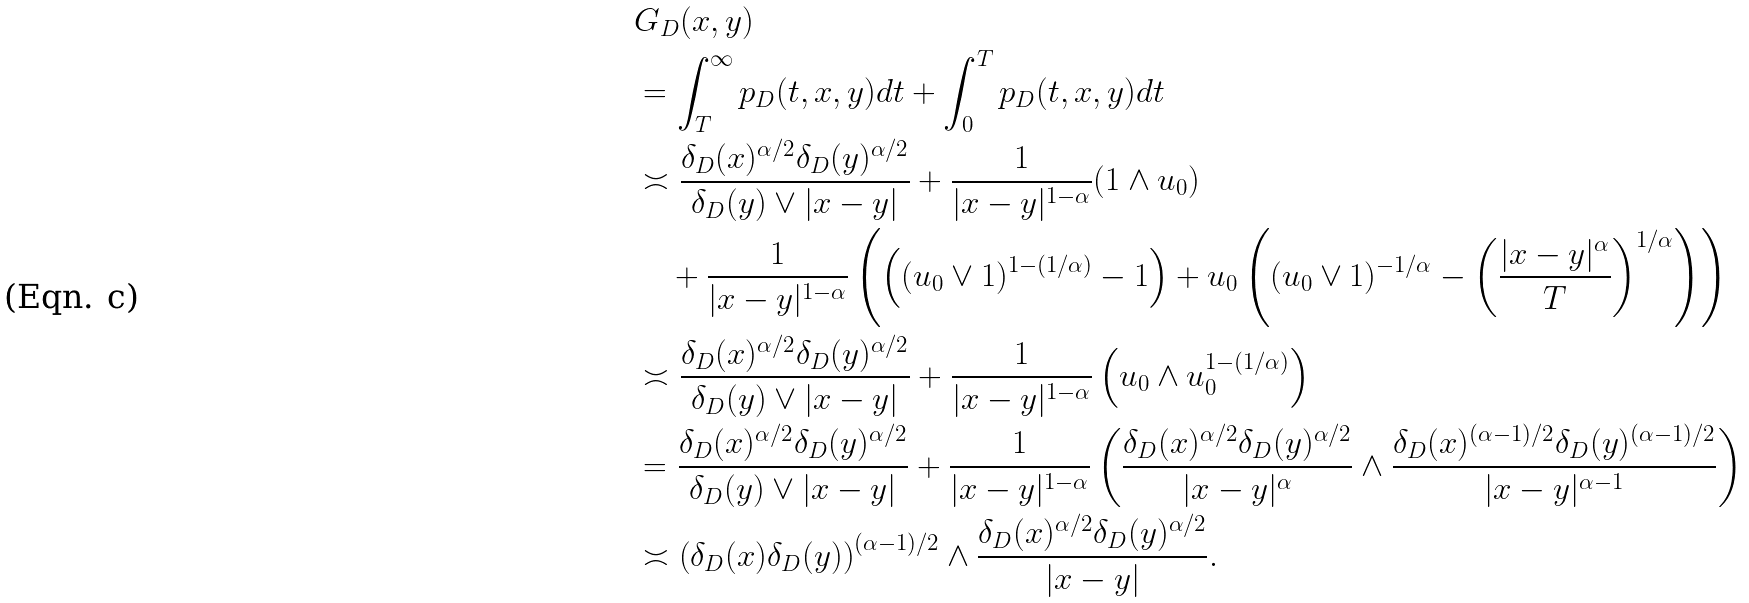Convert formula to latex. <formula><loc_0><loc_0><loc_500><loc_500>& G _ { D } ( x , y ) \\ & = \int _ { T } ^ { \infty } p _ { D } ( t , x , y ) d t + \int _ { 0 } ^ { T } p _ { D } ( t , x , y ) d t \\ & \asymp \frac { \delta _ { D } ( x ) ^ { \alpha / 2 } \delta _ { D } ( y ) ^ { \alpha / 2 } } { \delta _ { D } ( y ) \vee | x - y | } + \frac { 1 } { | x - y | ^ { 1 - \alpha } } ( 1 \wedge u _ { 0 } ) \\ & \quad + \frac { 1 } { | x - y | ^ { 1 - \alpha } } \left ( \left ( ( u _ { 0 } \vee 1 ) ^ { 1 - ( 1 / \alpha ) } - 1 \right ) + u _ { 0 } \left ( ( u _ { 0 } \vee 1 ) ^ { - 1 / \alpha } - \left ( \frac { | x - y | ^ { \alpha } } { T } \right ) ^ { 1 / \alpha } \right ) \right ) \\ & \asymp \frac { \delta _ { D } ( x ) ^ { \alpha / 2 } \delta _ { D } ( y ) ^ { \alpha / 2 } } { \delta _ { D } ( y ) \vee | x - y | } + \frac { 1 } { | x - y | ^ { 1 - \alpha } } \left ( u _ { 0 } \wedge u _ { 0 } ^ { 1 - ( 1 / \alpha ) } \right ) \\ & = \frac { \delta _ { D } ( x ) ^ { \alpha / 2 } \delta _ { D } ( y ) ^ { \alpha / 2 } } { \delta _ { D } ( y ) \vee | x - y | } + \frac { 1 } { | x - y | ^ { 1 - \alpha } } \left ( \frac { \delta _ { D } ( x ) ^ { \alpha / 2 } \delta _ { D } ( y ) ^ { \alpha / 2 } } { | x - y | ^ { \alpha } } \wedge \frac { \delta _ { D } ( x ) ^ { ( \alpha - 1 ) / 2 } \delta _ { D } ( y ) ^ { ( \alpha - 1 ) / 2 } } { | x - y | ^ { \alpha - 1 } } \right ) \\ & \asymp \left ( \delta _ { D } ( x ) \delta _ { D } ( y ) \right ) ^ { ( \alpha - 1 ) / 2 } \wedge \frac { \delta _ { D } ( x ) ^ { \alpha / 2 } \delta _ { D } ( y ) ^ { \alpha / 2 } } { | x - y | } .</formula> 